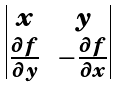Convert formula to latex. <formula><loc_0><loc_0><loc_500><loc_500>\begin{vmatrix} x & y \\ \frac { \partial f } { \partial y } & - \frac { \partial f } { \partial x } \end{vmatrix}</formula> 